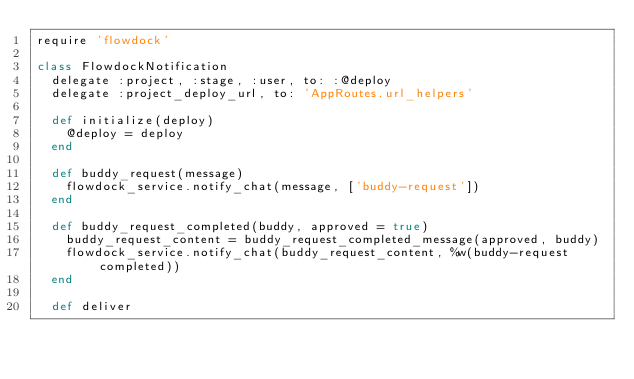<code> <loc_0><loc_0><loc_500><loc_500><_Ruby_>require 'flowdock'

class FlowdockNotification
  delegate :project, :stage, :user, to: :@deploy
  delegate :project_deploy_url, to: 'AppRoutes.url_helpers'

  def initialize(deploy)
    @deploy = deploy
  end

  def buddy_request(message)
    flowdock_service.notify_chat(message, ['buddy-request'])
  end

  def buddy_request_completed(buddy, approved = true)
    buddy_request_content = buddy_request_completed_message(approved, buddy)
    flowdock_service.notify_chat(buddy_request_content, %w(buddy-request completed))
  end

  def deliver</code> 